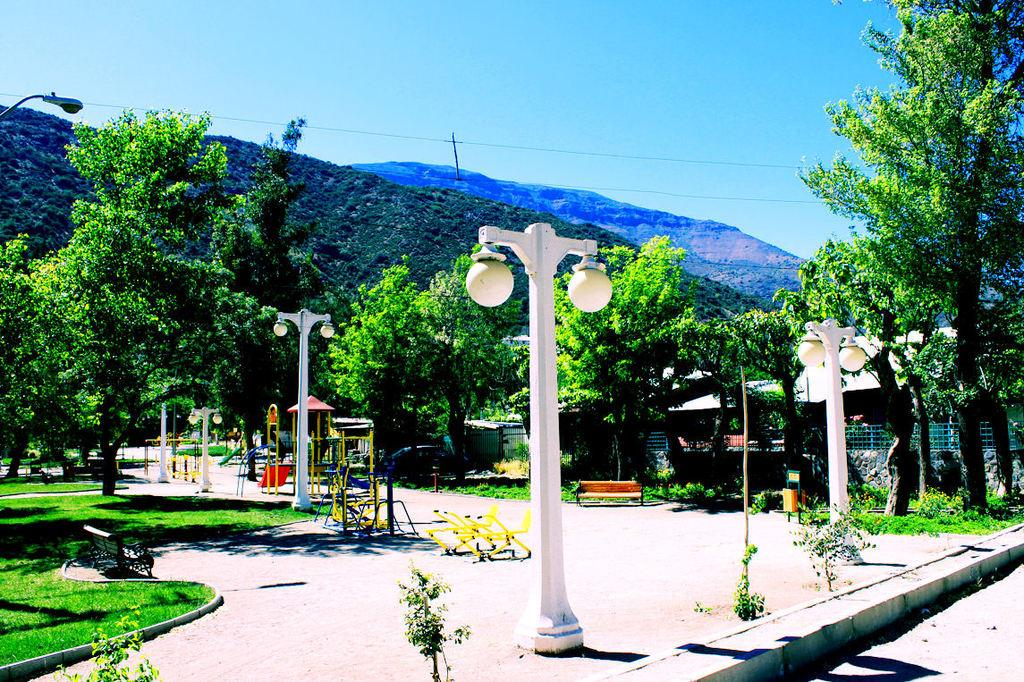What type of structures can be seen in the image? There are light poles, wooden benches, a wall, and houses in the image. What type of natural elements are present in the image? There are plants, grass, a play area, trees, hills, and the sky in the image. What type of surface is visible in the image? There is grass in the image. What type of objects can be seen in the image? There are light poles, wooden benches, a wall, houses, trees, and wires in the image. What color is the sky in the background of the image? The sky is blue in the background of the image. Where is the writer sitting with their vase in the image? There is no writer or vase present in the image. What type of train can be seen passing by in the image? There is no train present in the image. 